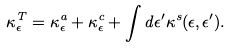<formula> <loc_0><loc_0><loc_500><loc_500>\kappa ^ { T } _ { \epsilon } = \kappa ^ { a } _ { \epsilon } + \kappa ^ { c } _ { \epsilon } + \int d \epsilon ^ { \prime } \kappa ^ { s } ( \epsilon , \epsilon ^ { \prime } ) .</formula> 